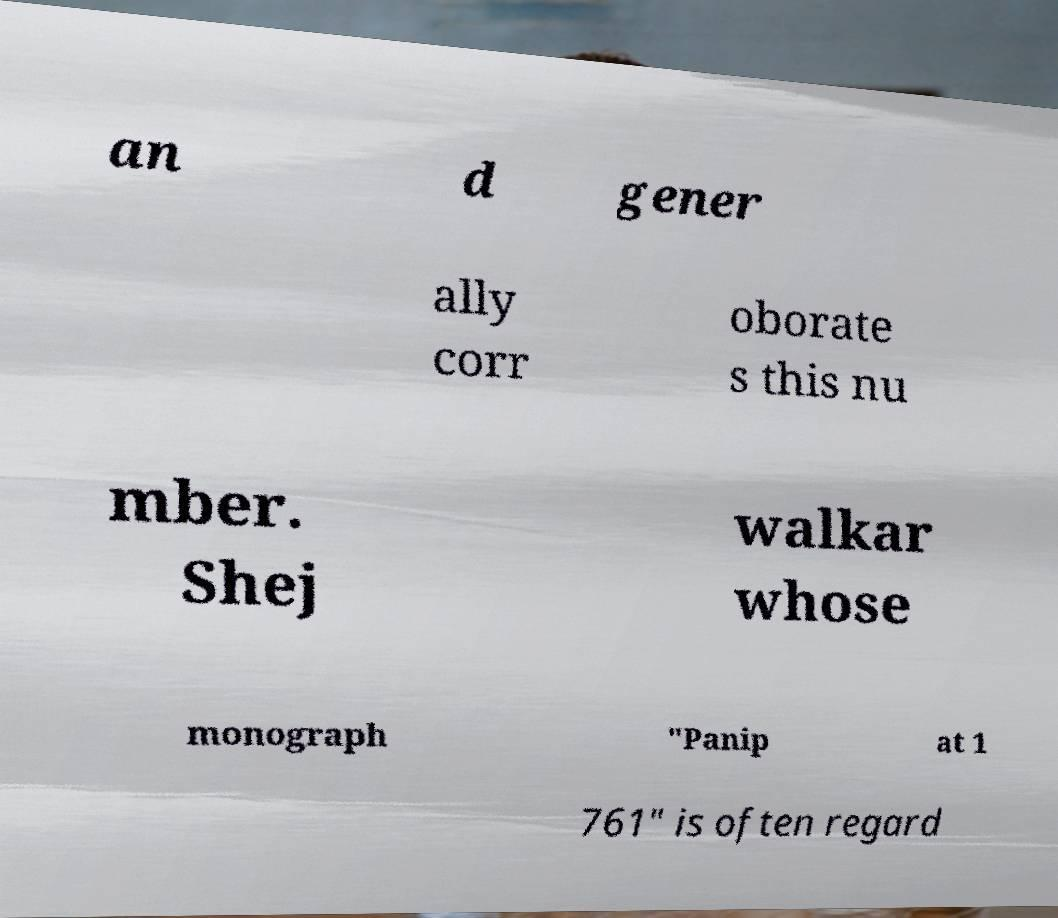What messages or text are displayed in this image? I need them in a readable, typed format. an d gener ally corr oborate s this nu mber. Shej walkar whose monograph "Panip at 1 761" is often regard 